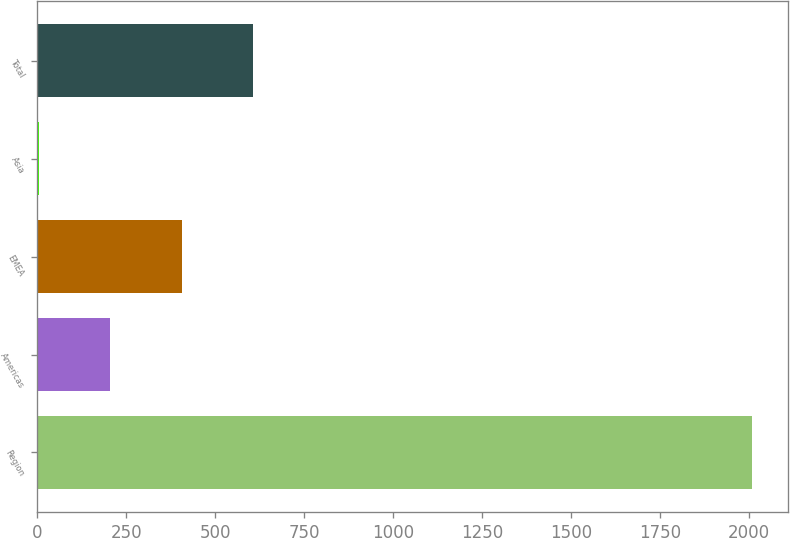Convert chart. <chart><loc_0><loc_0><loc_500><loc_500><bar_chart><fcel>Region<fcel>Americas<fcel>EMEA<fcel>Asia<fcel>Total<nl><fcel>2008<fcel>206.2<fcel>406.4<fcel>6<fcel>606.6<nl></chart> 